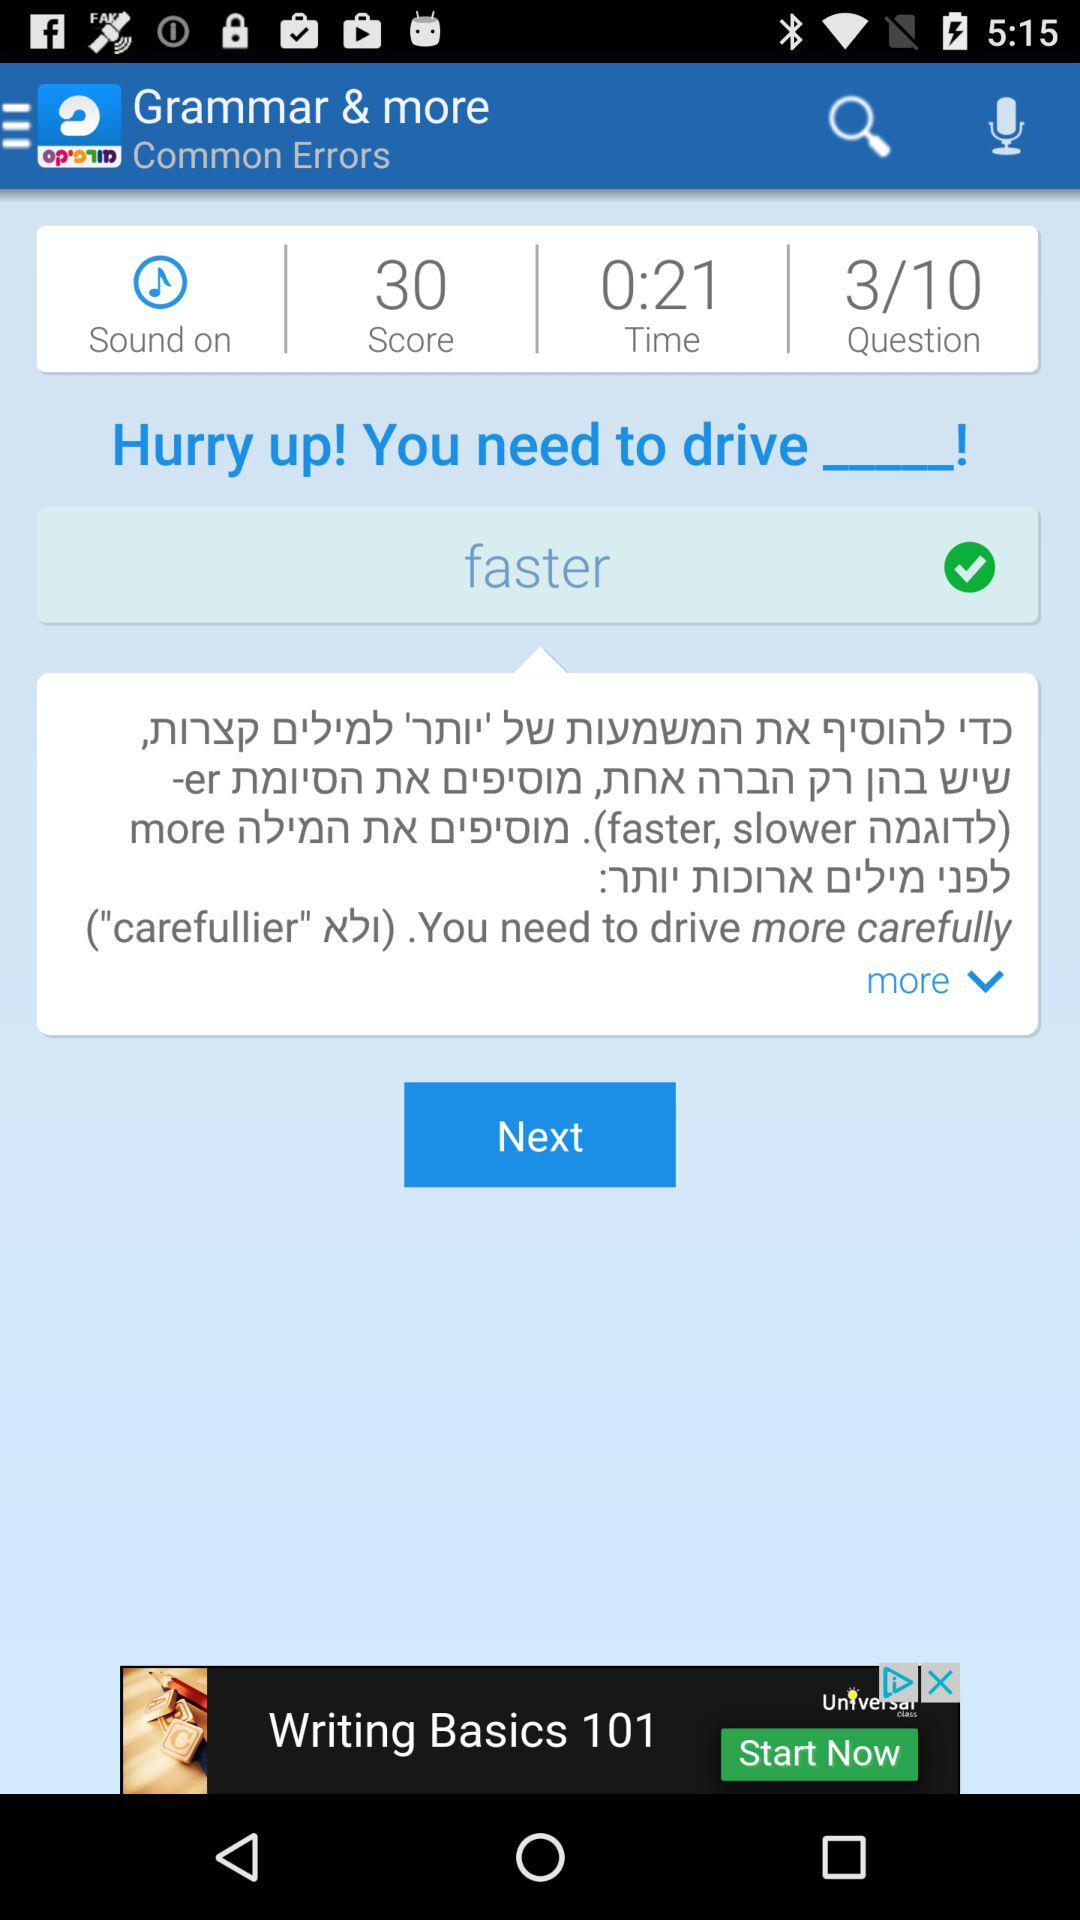What is the status of "Sound"? The status of "Sound" is "on". 